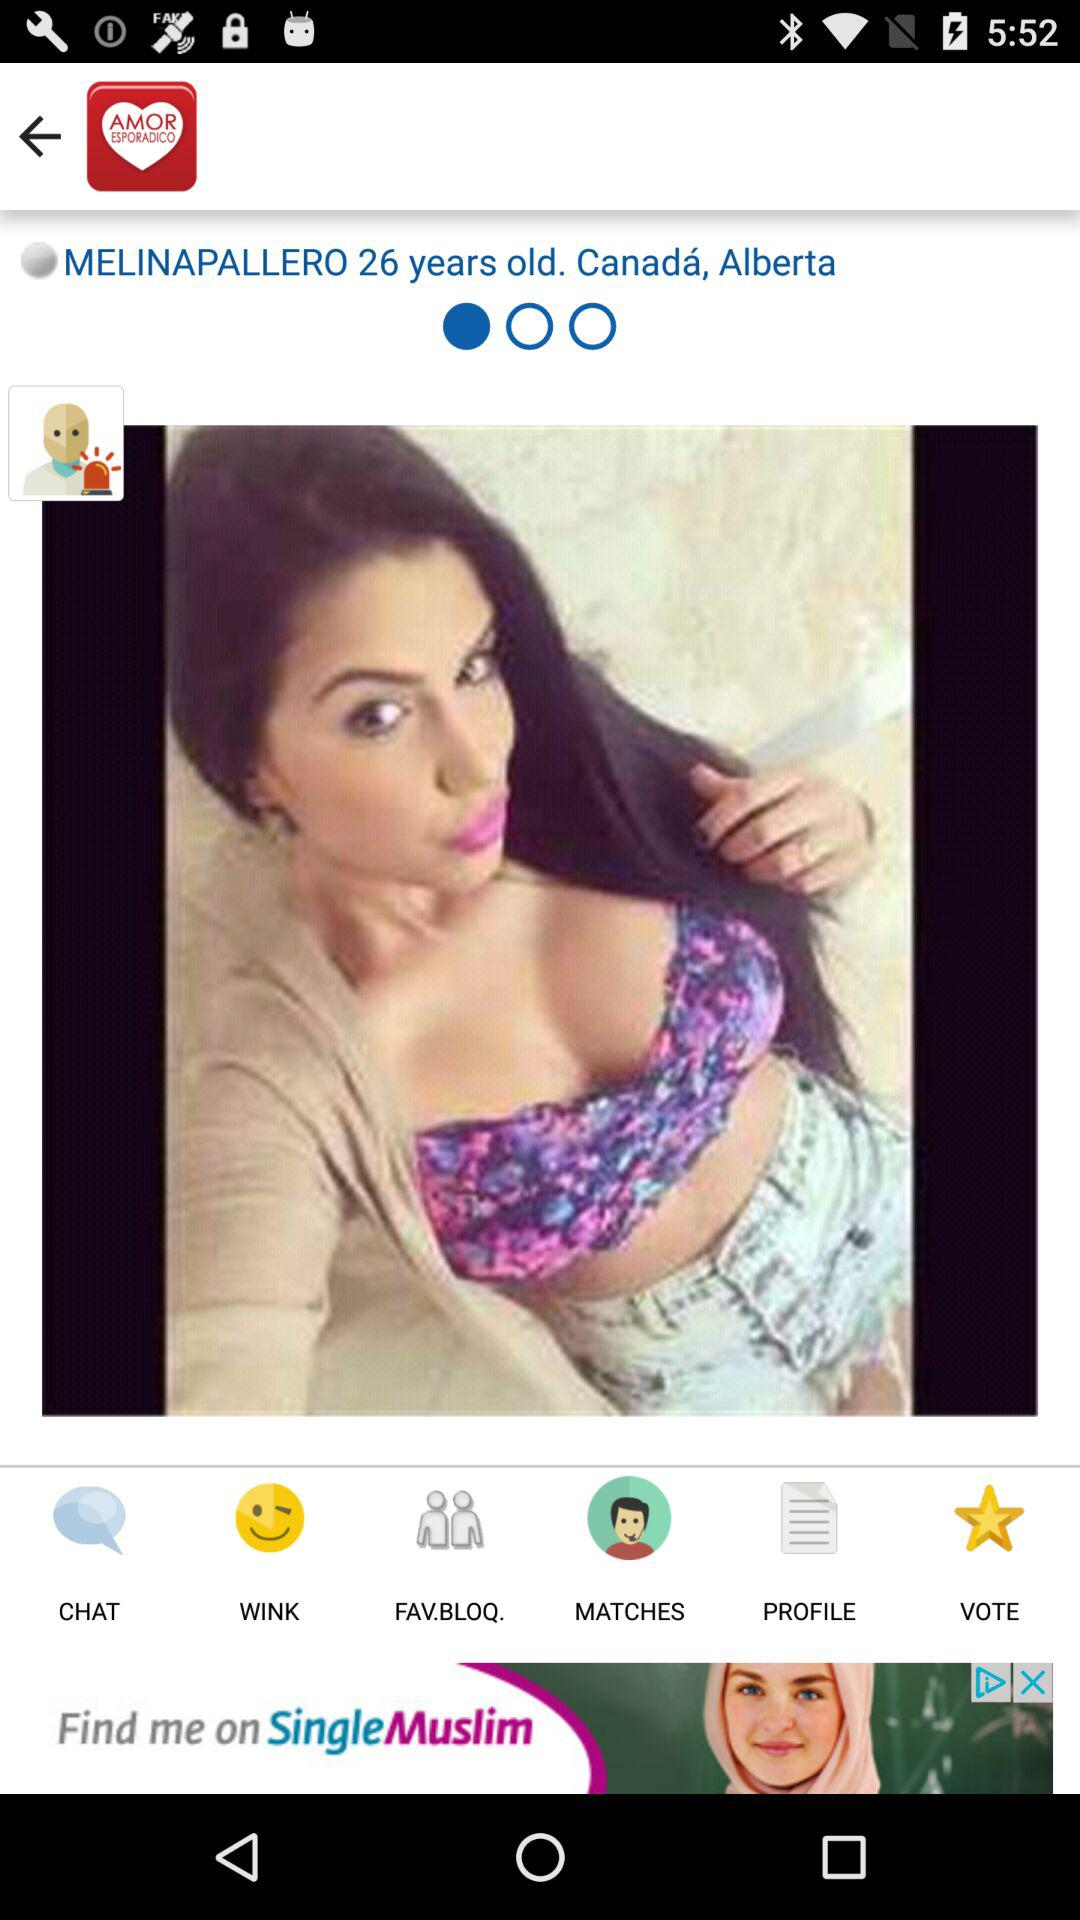Which country does Melinapallero live in? Melinapallero lives in Canada. 